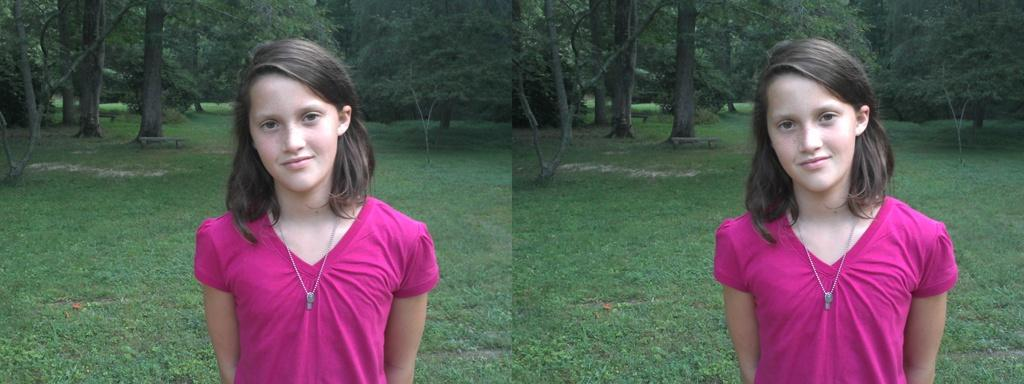How many images are combined in the collage? The image is a collage of two images. Who is the main subject in both images? Both images feature the same girl. What type of land is visible in the image? The land in the image is covered with grass. What can be seen in the background of the image? There are trees in the background of the image. What type of furniture is the girl sitting on in the image? There is no furniture present in the image; the girl is standing in both images. Does the girl express any regret in the image? There is no indication of regret in the image; the girl's emotions are not visible. 